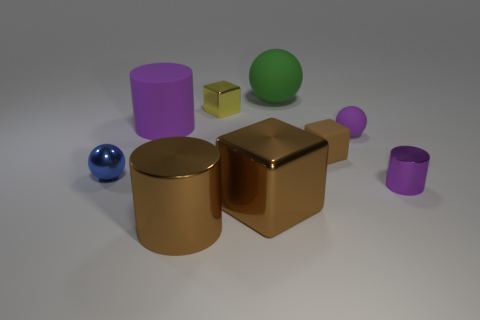There is a metallic thing that is to the right of the small purple sphere; what is its color?
Your response must be concise. Purple. There is a sphere that is the same color as the rubber cylinder; what is it made of?
Your answer should be compact. Rubber. What number of shiny blocks are the same color as the metallic ball?
Your answer should be very brief. 0. Does the purple metal cylinder have the same size as the brown block in front of the tiny shiny cylinder?
Provide a short and direct response. No. What is the size of the metallic cylinder that is behind the cylinder in front of the purple object in front of the purple sphere?
Give a very brief answer. Small. What number of blue spheres are on the right side of the large green ball?
Ensure brevity in your answer.  0. What material is the thing behind the shiny thing behind the large rubber cylinder made of?
Give a very brief answer. Rubber. Are there any other things that have the same size as the brown matte object?
Your answer should be compact. Yes. Do the purple metal thing and the green rubber sphere have the same size?
Offer a very short reply. No. How many objects are purple rubber things right of the large green matte ball or spheres that are right of the blue object?
Ensure brevity in your answer.  2. 